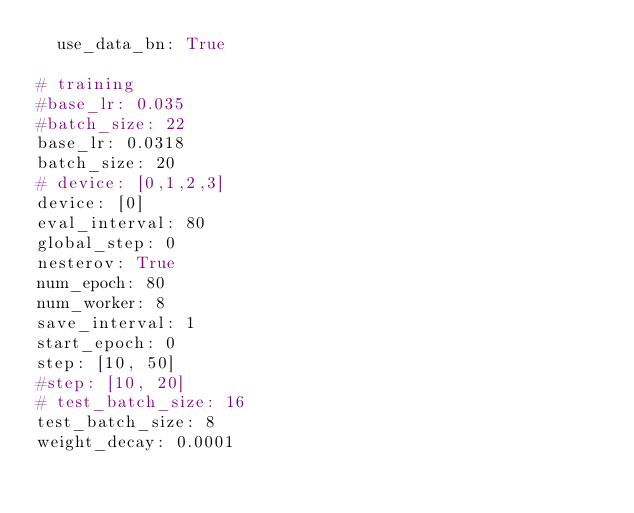<code> <loc_0><loc_0><loc_500><loc_500><_YAML_>  use_data_bn: True 

# training
#base_lr: 0.035
#batch_size: 22
base_lr: 0.0318
batch_size: 20
# device: [0,1,2,3]
device: [0]
eval_interval: 80
global_step: 0
nesterov: True
num_epoch: 80
num_worker: 8
save_interval: 1
start_epoch: 0
step: [10, 50]
#step: [10, 20]
# test_batch_size: 16
test_batch_size: 8
weight_decay: 0.0001



</code> 